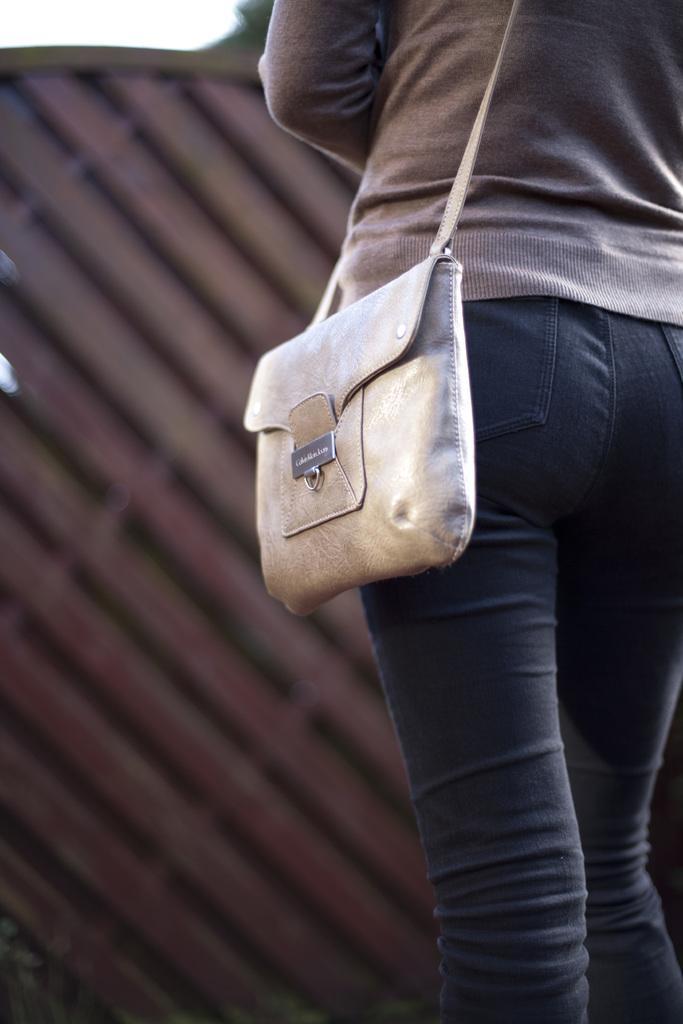Could you give a brief overview of what you see in this image? In this image I can see a person wearing the bag. In front of her there is a sky and something else. 